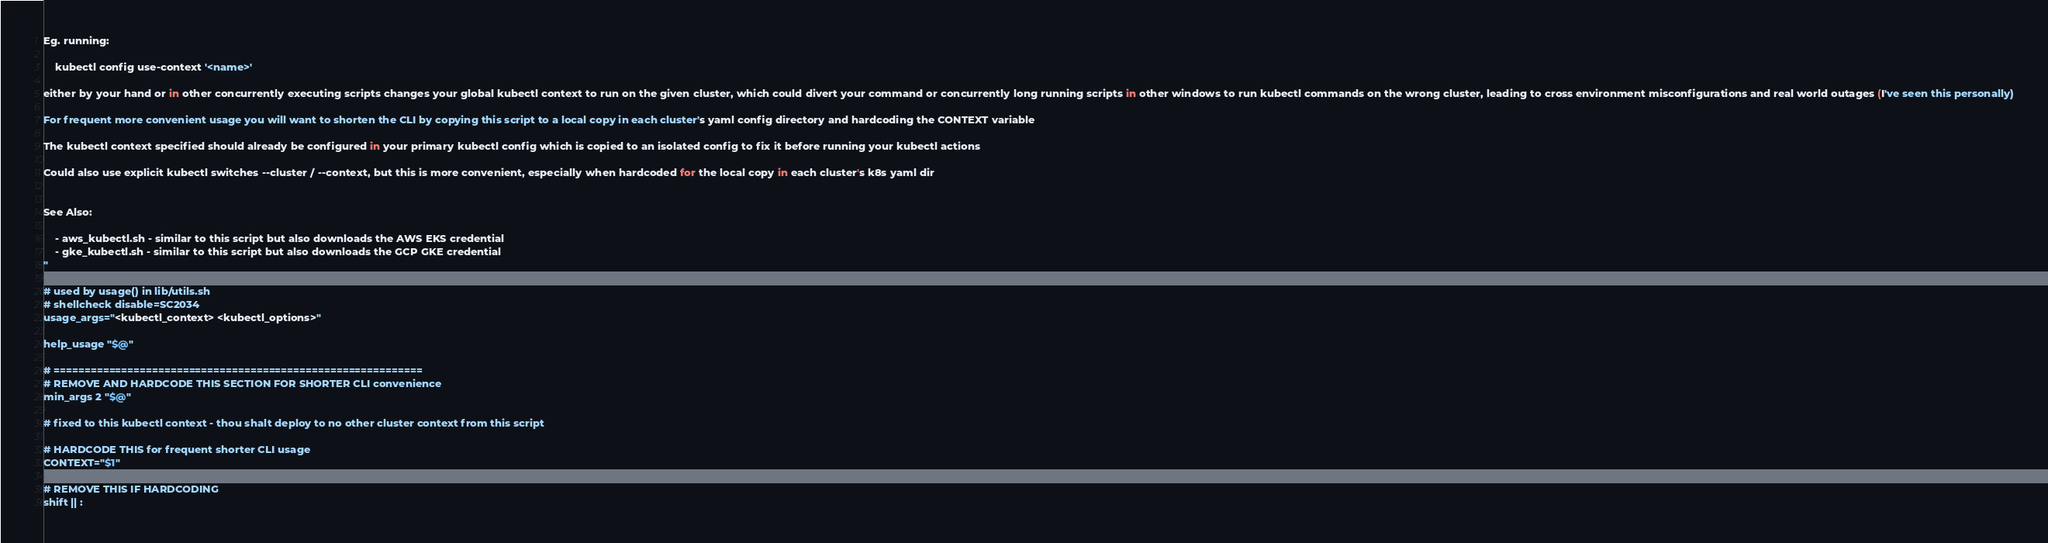<code> <loc_0><loc_0><loc_500><loc_500><_Bash_>
Eg. running:

    kubectl config use-context '<name>'

either by your hand or in other concurrently executing scripts changes your global kubectl context to run on the given cluster, which could divert your command or concurrently long running scripts in other windows to run kubectl commands on the wrong cluster, leading to cross environment misconfigurations and real world outages (I've seen this personally)

For frequent more convenient usage you will want to shorten the CLI by copying this script to a local copy in each cluster's yaml config directory and hardcoding the CONTEXT variable

The kubectl context specified should already be configured in your primary kubectl config which is copied to an isolated config to fix it before running your kubectl actions

Could also use explicit kubectl switches --cluster / --context, but this is more convenient, especially when hardcoded for the local copy in each cluster's k8s yaml dir


See Also:

    - aws_kubectl.sh - similar to this script but also downloads the AWS EKS credential
    - gke_kubectl.sh - similar to this script but also downloads the GCP GKE credential
"

# used by usage() in lib/utils.sh
# shellcheck disable=SC2034
usage_args="<kubectl_context> <kubectl_options>"

help_usage "$@"

# ============================================================
# REMOVE AND HARDCODE THIS SECTION FOR SHORTER CLI convenience
min_args 2 "$@"

# fixed to this kubectl context - thou shalt deploy to no other cluster context from this script

# HARDCODE THIS for frequent shorter CLI usage
CONTEXT="$1"

# REMOVE THIS IF HARDCODING
shift || :</code> 